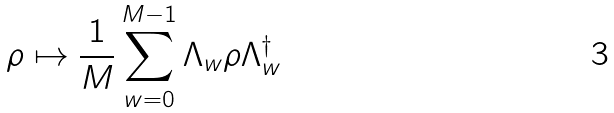Convert formula to latex. <formula><loc_0><loc_0><loc_500><loc_500>\rho \mapsto \frac { 1 } { M } \sum _ { w = 0 } ^ { M - 1 } \Lambda _ { w } \rho \Lambda _ { w } ^ { \dagger }</formula> 